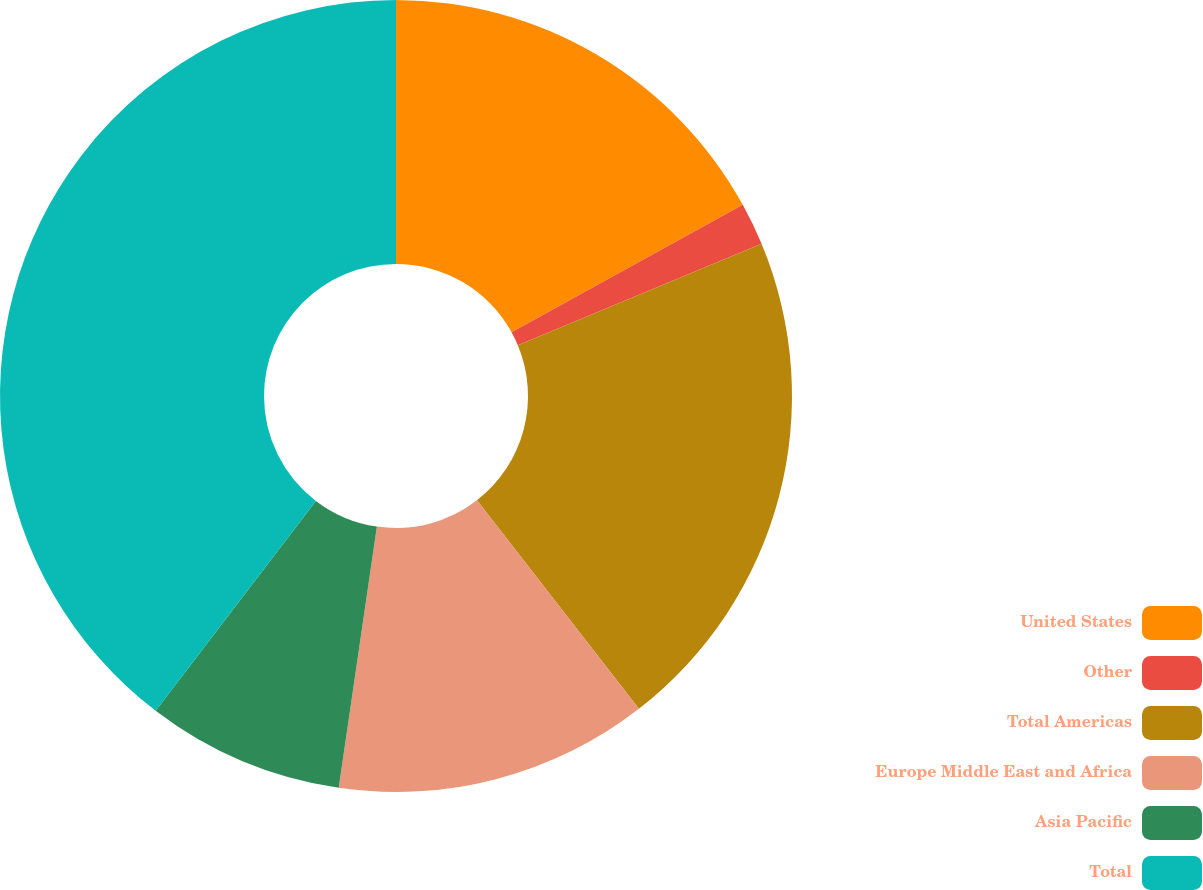Convert chart to OTSL. <chart><loc_0><loc_0><loc_500><loc_500><pie_chart><fcel>United States<fcel>Other<fcel>Total Americas<fcel>Europe Middle East and Africa<fcel>Asia Pacific<fcel>Total<nl><fcel>16.98%<fcel>1.74%<fcel>20.77%<fcel>12.82%<fcel>8.07%<fcel>39.62%<nl></chart> 